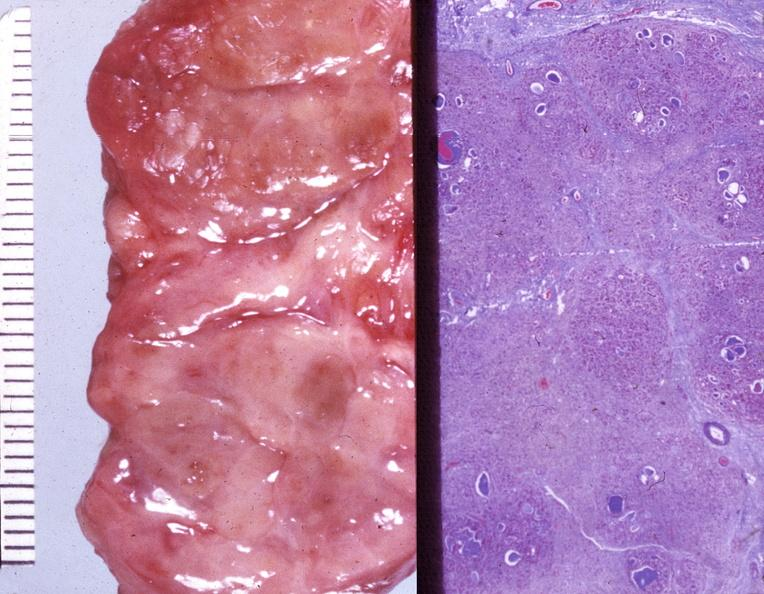does atrophy show thyroid, hashimotos?
Answer the question using a single word or phrase. No 